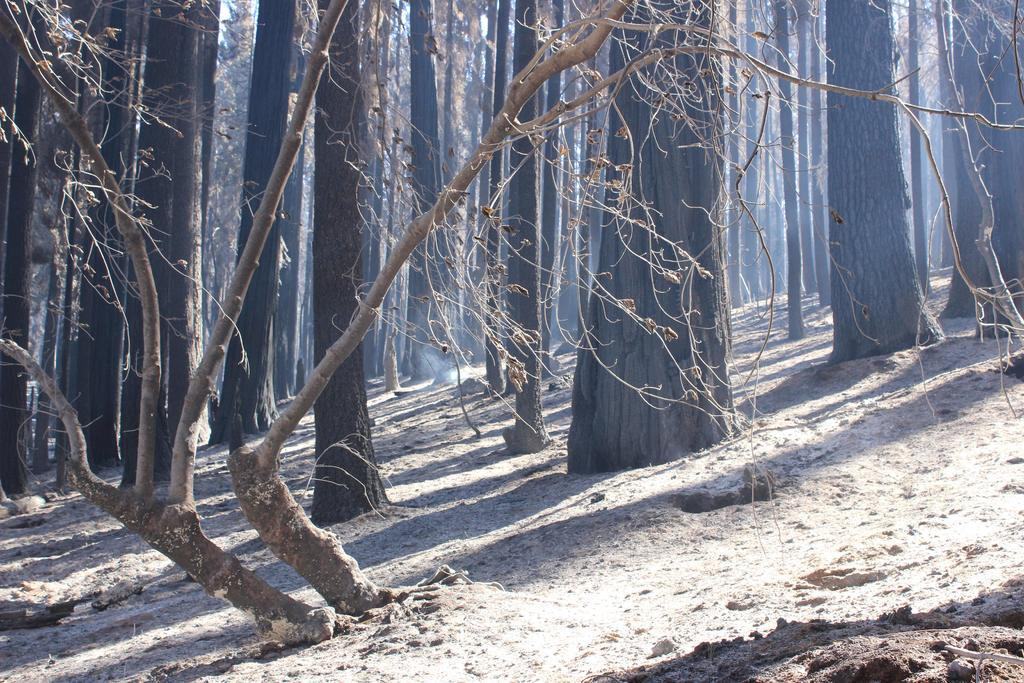What is the primary feature of the image? The primary feature of the image is the presence of many trees. Where are the trees located in the image? The trees are on the ground in the image. What type of glue is being used to hold the trees together in the image? There is no glue present in the image, and the trees are not being held together. 